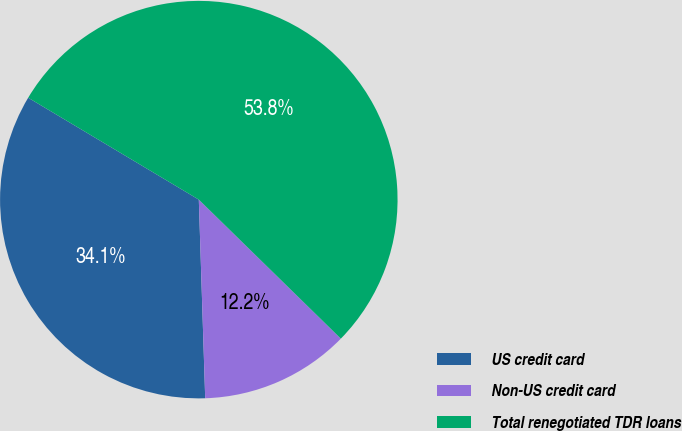<chart> <loc_0><loc_0><loc_500><loc_500><pie_chart><fcel>US credit card<fcel>Non-US credit card<fcel>Total renegotiated TDR loans<nl><fcel>34.08%<fcel>12.16%<fcel>53.76%<nl></chart> 